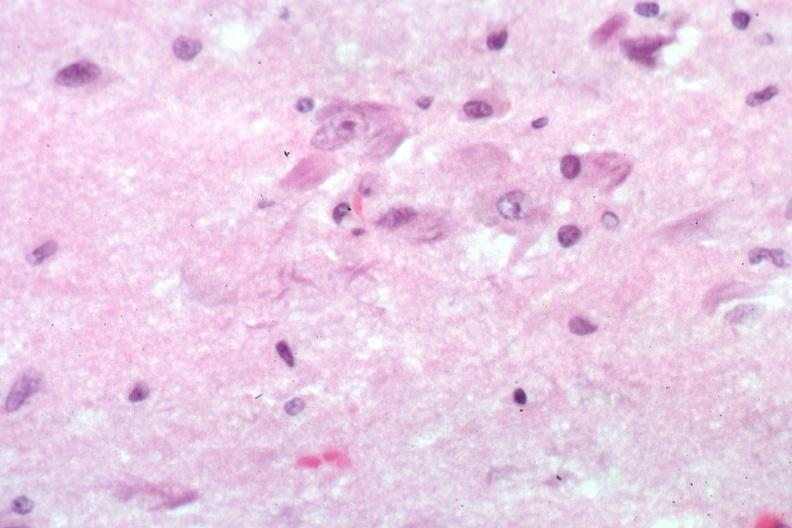s senile plaque present?
Answer the question using a single word or phrase. Yes 